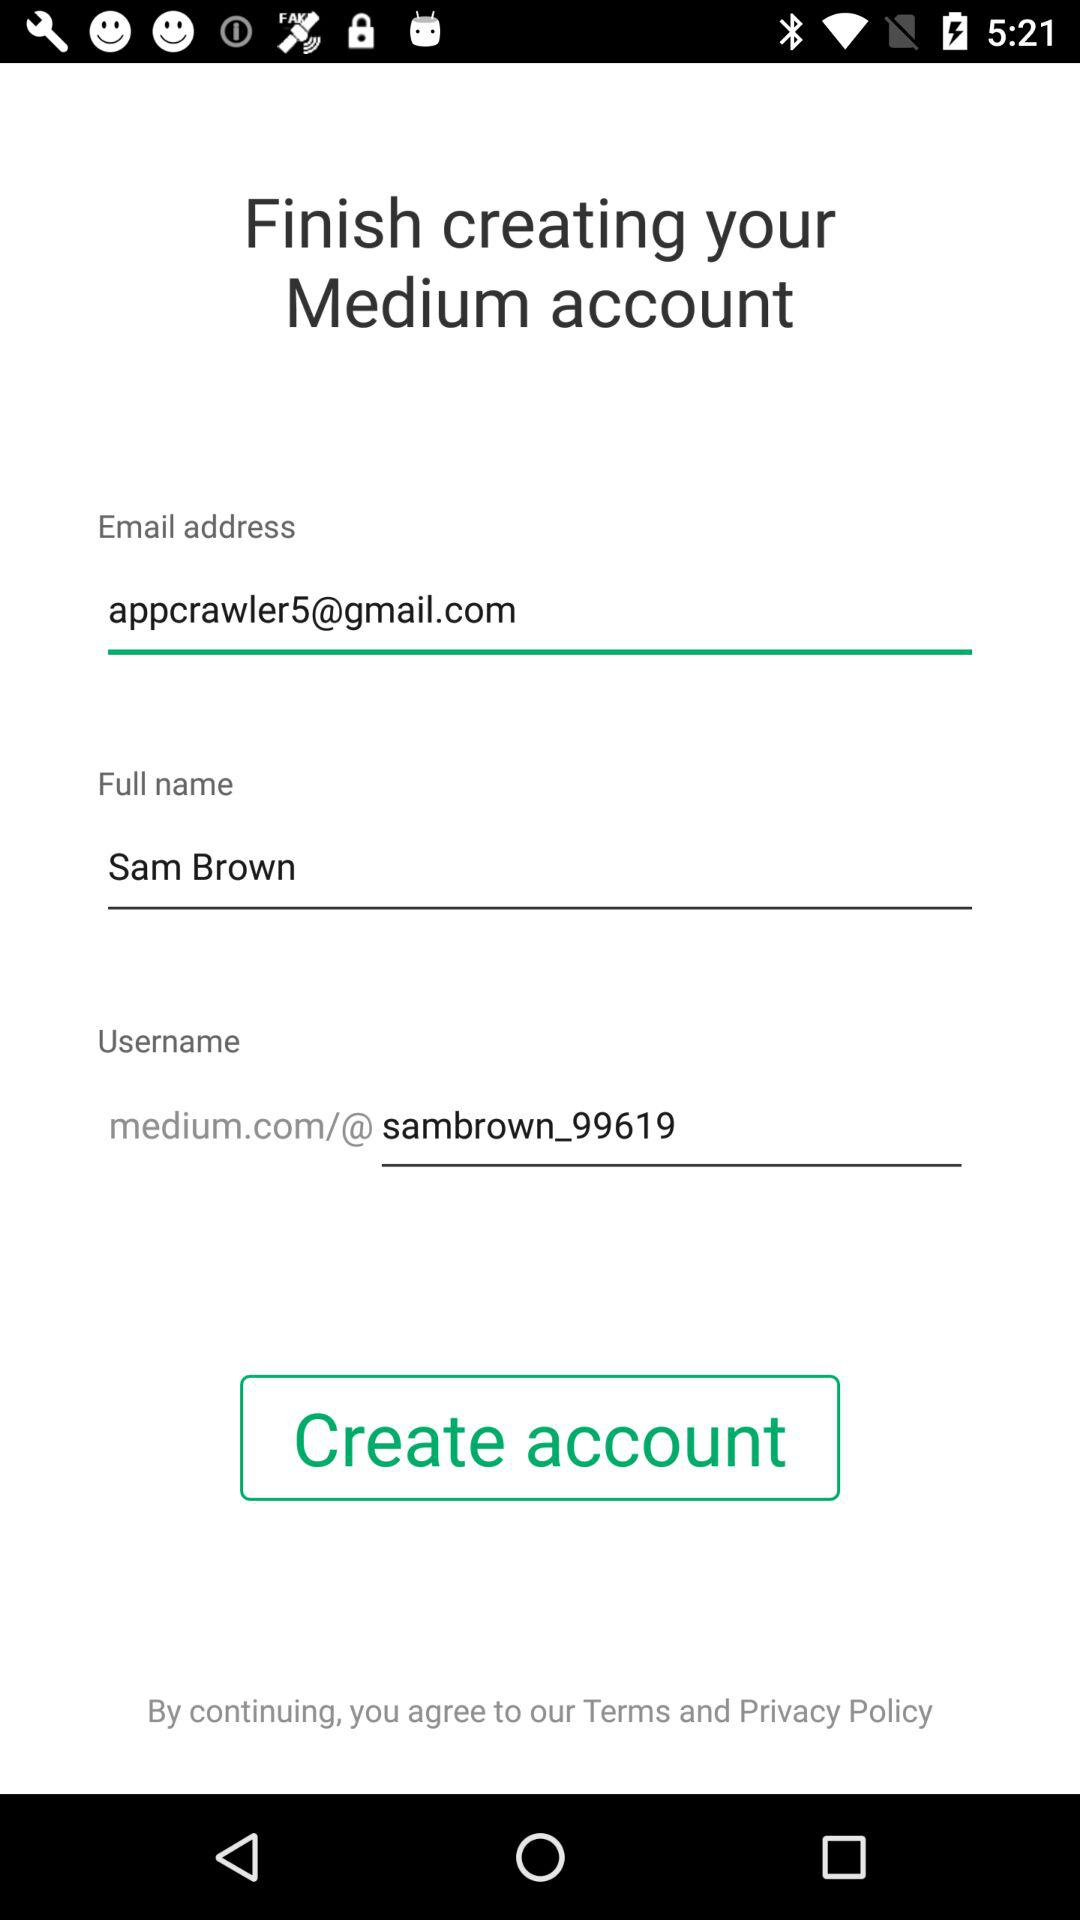What is the full name? The full name is Sam Brown. 